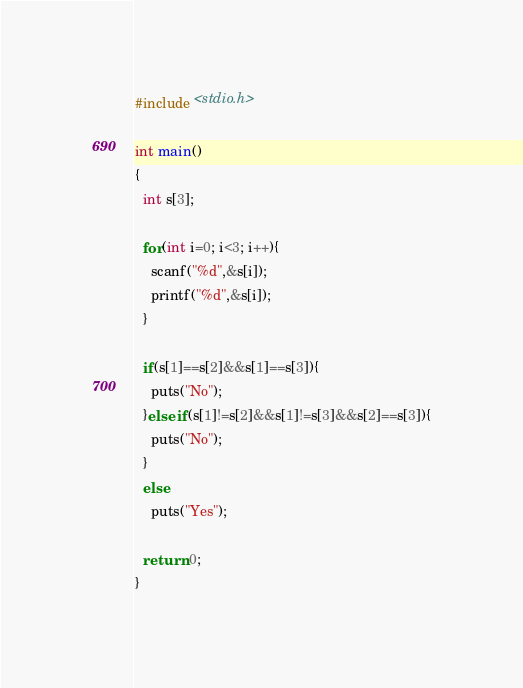<code> <loc_0><loc_0><loc_500><loc_500><_C_>#include <stdio.h>
 
int main()
{
  int s[3];
  
  for(int i=0; i<3; i++){
    scanf("%d",&s[i]);
    printf("%d",&s[i]);
  }
  
  if(s[1]==s[2]&&s[1]==s[3]){
    puts("No");
  }else if(s[1]!=s[2]&&s[1]!=s[3]&&s[2]==s[3]){
    puts("No");
  }
  else
    puts("Yes");
  
  return 0;
}</code> 